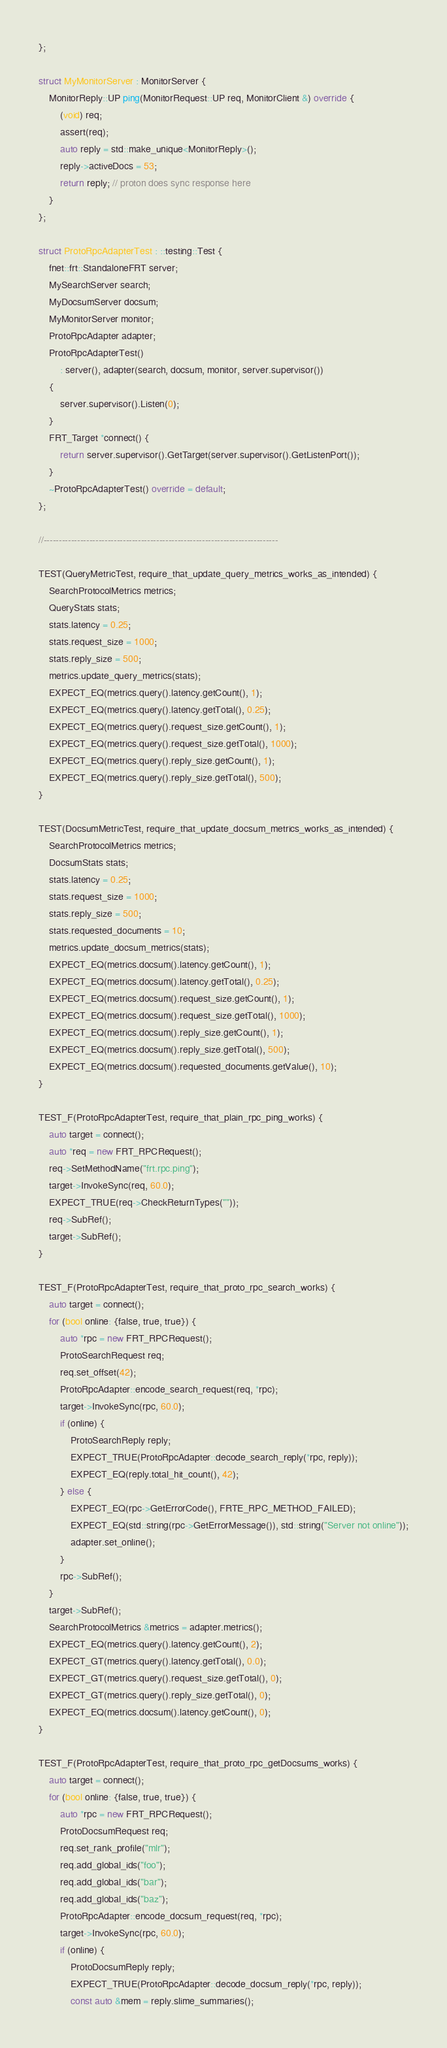Convert code to text. <code><loc_0><loc_0><loc_500><loc_500><_C++_>};

struct MyMonitorServer : MonitorServer {
    MonitorReply::UP ping(MonitorRequest::UP req, MonitorClient &) override {
        (void) req;
        assert(req);
        auto reply = std::make_unique<MonitorReply>();
        reply->activeDocs = 53;
        return reply; // proton does sync response here
    }
};

struct ProtoRpcAdapterTest : ::testing::Test {
    fnet::frt::StandaloneFRT server;
    MySearchServer search;
    MyDocsumServer docsum;
    MyMonitorServer monitor;
    ProtoRpcAdapter adapter;
    ProtoRpcAdapterTest()
        : server(), adapter(search, docsum, monitor, server.supervisor())
    {
        server.supervisor().Listen(0);
    }
    FRT_Target *connect() {
        return server.supervisor().GetTarget(server.supervisor().GetListenPort());
    }
    ~ProtoRpcAdapterTest() override = default;
};

//-----------------------------------------------------------------------------

TEST(QueryMetricTest, require_that_update_query_metrics_works_as_intended) {
    SearchProtocolMetrics metrics;
    QueryStats stats;
    stats.latency = 0.25;
    stats.request_size = 1000;
    stats.reply_size = 500;
    metrics.update_query_metrics(stats);
    EXPECT_EQ(metrics.query().latency.getCount(), 1);
    EXPECT_EQ(metrics.query().latency.getTotal(), 0.25);
    EXPECT_EQ(metrics.query().request_size.getCount(), 1);
    EXPECT_EQ(metrics.query().request_size.getTotal(), 1000);
    EXPECT_EQ(metrics.query().reply_size.getCount(), 1);
    EXPECT_EQ(metrics.query().reply_size.getTotal(), 500);
}

TEST(DocsumMetricTest, require_that_update_docsum_metrics_works_as_intended) {
    SearchProtocolMetrics metrics;
    DocsumStats stats;
    stats.latency = 0.25;
    stats.request_size = 1000;
    stats.reply_size = 500;
    stats.requested_documents = 10;
    metrics.update_docsum_metrics(stats);
    EXPECT_EQ(metrics.docsum().latency.getCount(), 1);
    EXPECT_EQ(metrics.docsum().latency.getTotal(), 0.25);
    EXPECT_EQ(metrics.docsum().request_size.getCount(), 1);
    EXPECT_EQ(metrics.docsum().request_size.getTotal(), 1000);
    EXPECT_EQ(metrics.docsum().reply_size.getCount(), 1);
    EXPECT_EQ(metrics.docsum().reply_size.getTotal(), 500);
    EXPECT_EQ(metrics.docsum().requested_documents.getValue(), 10);
}

TEST_F(ProtoRpcAdapterTest, require_that_plain_rpc_ping_works) {
    auto target = connect();
    auto *req = new FRT_RPCRequest();
    req->SetMethodName("frt.rpc.ping");
    target->InvokeSync(req, 60.0);
    EXPECT_TRUE(req->CheckReturnTypes(""));
    req->SubRef();
    target->SubRef();
}

TEST_F(ProtoRpcAdapterTest, require_that_proto_rpc_search_works) {
    auto target = connect();
    for (bool online: {false, true, true}) {
        auto *rpc = new FRT_RPCRequest();
        ProtoSearchRequest req;
        req.set_offset(42);
        ProtoRpcAdapter::encode_search_request(req, *rpc);
        target->InvokeSync(rpc, 60.0);
        if (online) {
            ProtoSearchReply reply;
            EXPECT_TRUE(ProtoRpcAdapter::decode_search_reply(*rpc, reply));
            EXPECT_EQ(reply.total_hit_count(), 42);
        } else {
            EXPECT_EQ(rpc->GetErrorCode(), FRTE_RPC_METHOD_FAILED);
            EXPECT_EQ(std::string(rpc->GetErrorMessage()), std::string("Server not online"));
            adapter.set_online();
        }
        rpc->SubRef();
    }
    target->SubRef();
    SearchProtocolMetrics &metrics = adapter.metrics();
    EXPECT_EQ(metrics.query().latency.getCount(), 2);
    EXPECT_GT(metrics.query().latency.getTotal(), 0.0);
    EXPECT_GT(metrics.query().request_size.getTotal(), 0);
    EXPECT_GT(metrics.query().reply_size.getTotal(), 0);
    EXPECT_EQ(metrics.docsum().latency.getCount(), 0);
}

TEST_F(ProtoRpcAdapterTest, require_that_proto_rpc_getDocsums_works) {
    auto target = connect();
    for (bool online: {false, true, true}) {
        auto *rpc = new FRT_RPCRequest();
        ProtoDocsumRequest req;
        req.set_rank_profile("mlr");
        req.add_global_ids("foo");
        req.add_global_ids("bar");
        req.add_global_ids("baz");
        ProtoRpcAdapter::encode_docsum_request(req, *rpc);
        target->InvokeSync(rpc, 60.0);
        if (online) {
            ProtoDocsumReply reply;
            EXPECT_TRUE(ProtoRpcAdapter::decode_docsum_reply(*rpc, reply));
            const auto &mem = reply.slime_summaries();</code> 